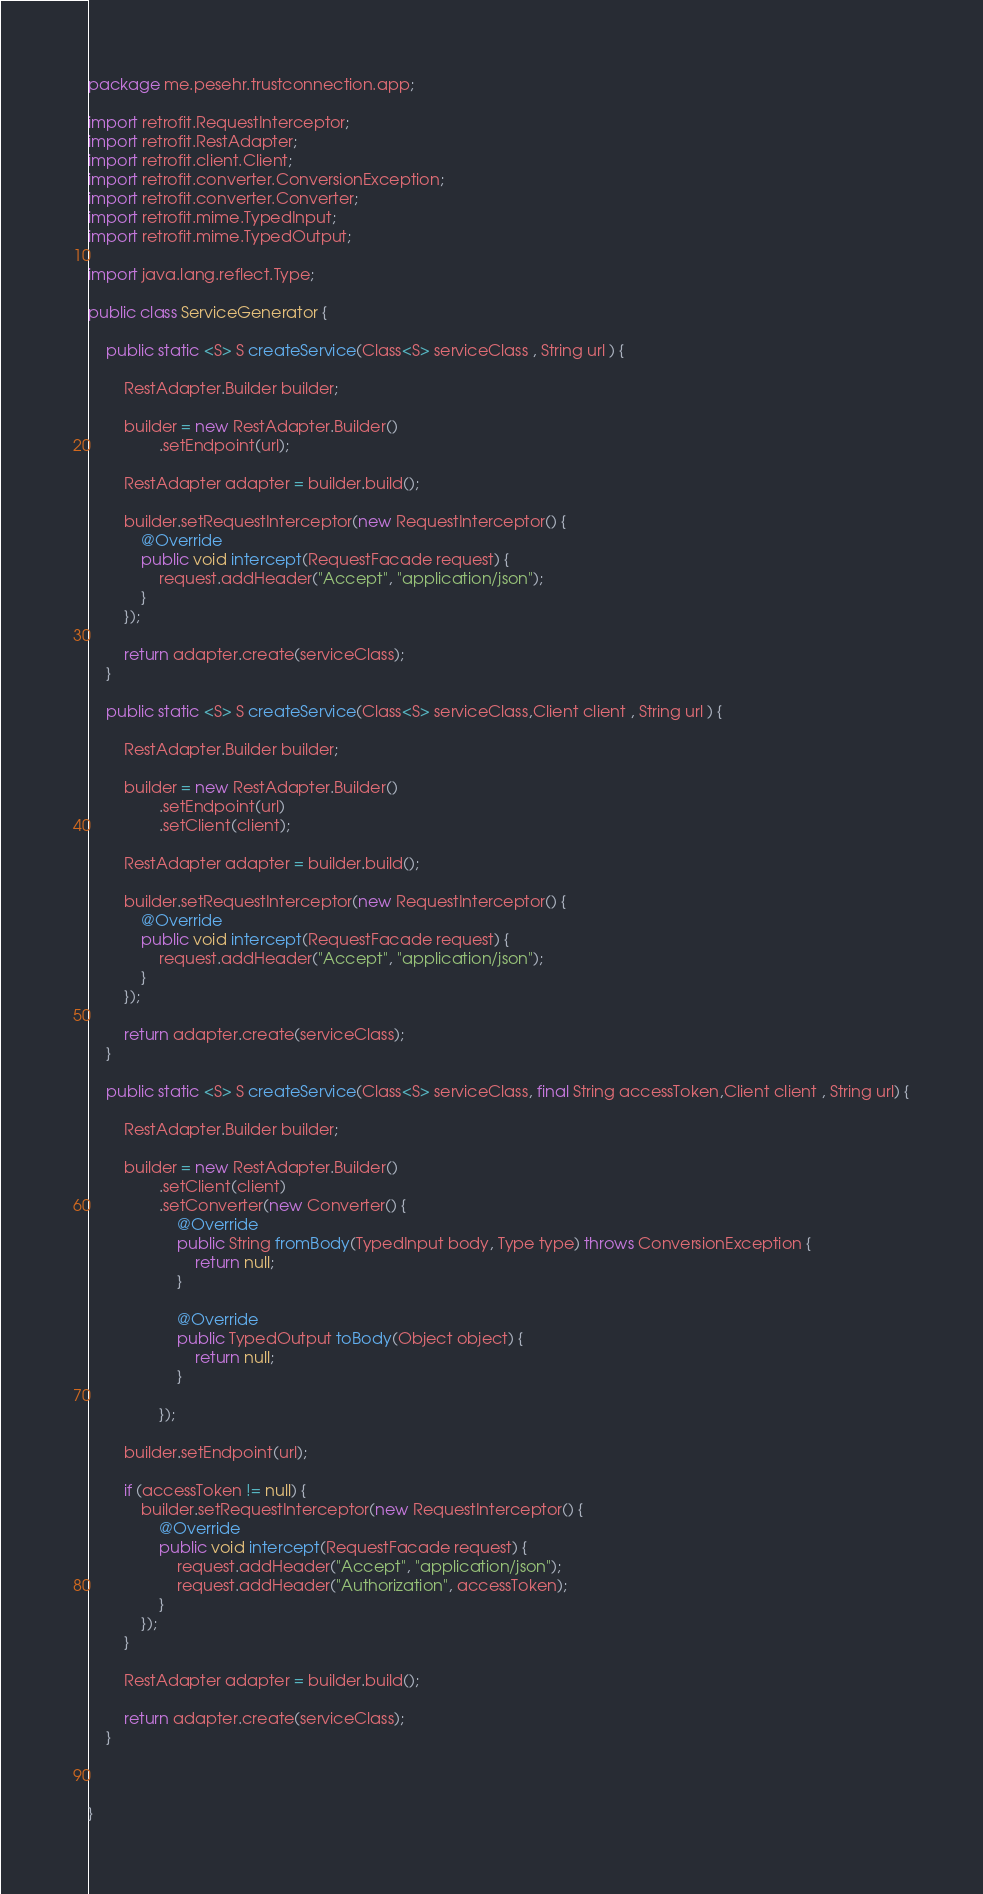Convert code to text. <code><loc_0><loc_0><loc_500><loc_500><_Java_>package me.pesehr.trustconnection.app;

import retrofit.RequestInterceptor;
import retrofit.RestAdapter;
import retrofit.client.Client;
import retrofit.converter.ConversionException;
import retrofit.converter.Converter;
import retrofit.mime.TypedInput;
import retrofit.mime.TypedOutput;

import java.lang.reflect.Type;

public class ServiceGenerator {

    public static <S> S createService(Class<S> serviceClass , String url ) {

        RestAdapter.Builder builder;

        builder = new RestAdapter.Builder()
                .setEndpoint(url);

        RestAdapter adapter = builder.build();

        builder.setRequestInterceptor(new RequestInterceptor() {
            @Override
            public void intercept(RequestFacade request) {
                request.addHeader("Accept", "application/json");
            }
        });

        return adapter.create(serviceClass);
    }

    public static <S> S createService(Class<S> serviceClass,Client client , String url ) {

        RestAdapter.Builder builder;

        builder = new RestAdapter.Builder()
                .setEndpoint(url)
                .setClient(client);

        RestAdapter adapter = builder.build();

        builder.setRequestInterceptor(new RequestInterceptor() {
            @Override
            public void intercept(RequestFacade request) {
                request.addHeader("Accept", "application/json");
            }
        });

        return adapter.create(serviceClass);
    }

    public static <S> S createService(Class<S> serviceClass, final String accessToken,Client client , String url) {

        RestAdapter.Builder builder;

        builder = new RestAdapter.Builder()
                .setClient(client)
                .setConverter(new Converter() {
                    @Override
                    public String fromBody(TypedInput body, Type type) throws ConversionException {
                        return null;
                    }

                    @Override
                    public TypedOutput toBody(Object object) {
                        return null;
                    }

                });

        builder.setEndpoint(url);

        if (accessToken != null) {
            builder.setRequestInterceptor(new RequestInterceptor() {
                @Override
                public void intercept(RequestFacade request) {
                    request.addHeader("Accept", "application/json");
                    request.addHeader("Authorization", accessToken);
                }
            });
        }

        RestAdapter adapter = builder.build();

        return adapter.create(serviceClass);
    }



}</code> 